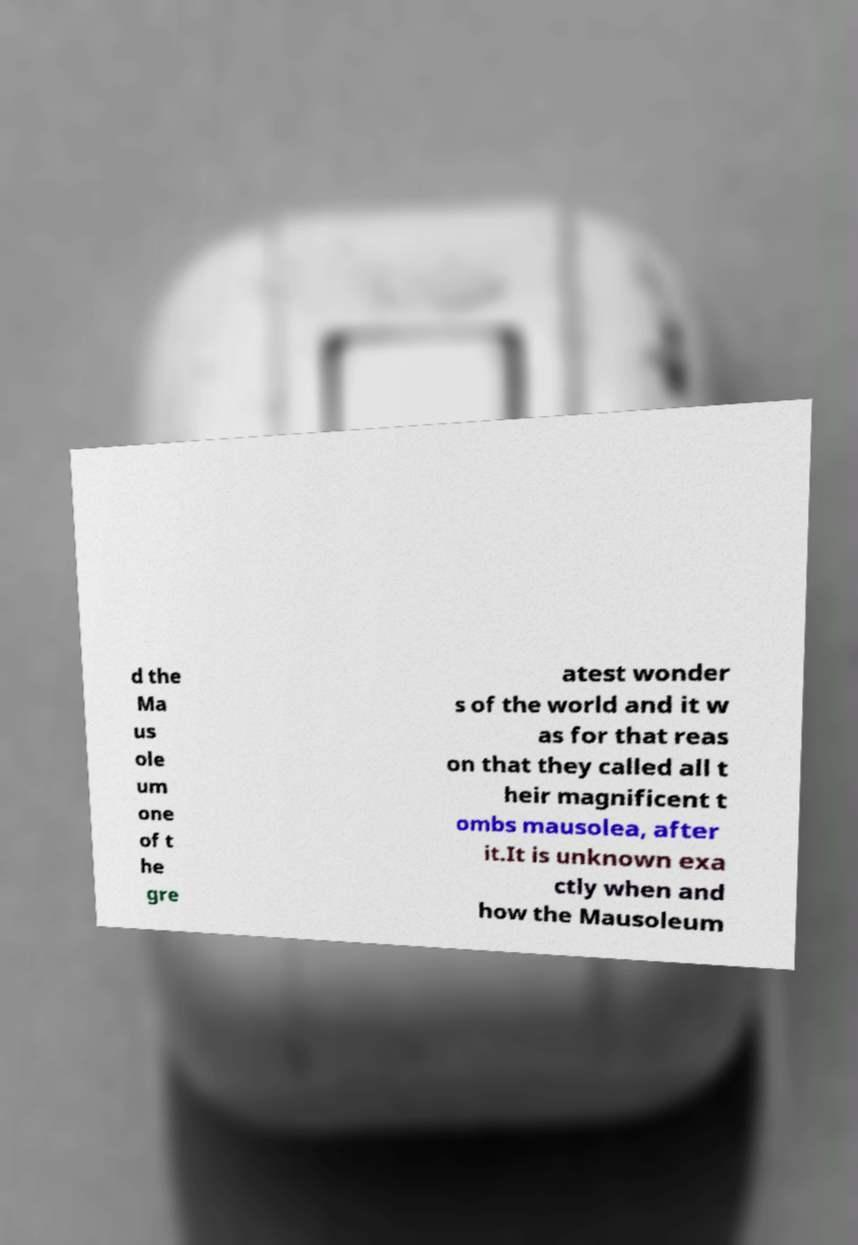Can you accurately transcribe the text from the provided image for me? d the Ma us ole um one of t he gre atest wonder s of the world and it w as for that reas on that they called all t heir magnificent t ombs mausolea, after it.It is unknown exa ctly when and how the Mausoleum 